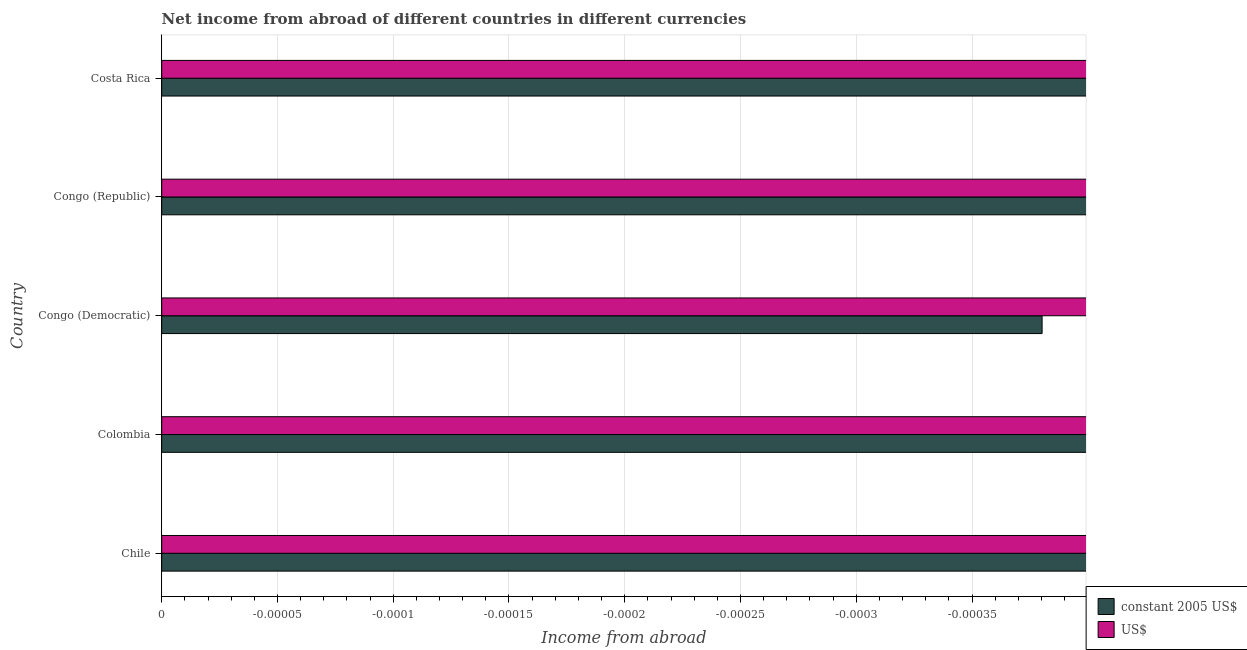How many bars are there on the 5th tick from the top?
Provide a succinct answer. 0. How many bars are there on the 5th tick from the bottom?
Provide a short and direct response. 0. What is the label of the 2nd group of bars from the top?
Ensure brevity in your answer.  Congo (Republic). What is the total income from abroad in us$ in the graph?
Offer a very short reply. 0. What is the difference between the income from abroad in constant 2005 us$ in Costa Rica and the income from abroad in us$ in Congo (Democratic)?
Give a very brief answer. 0. How many bars are there?
Your response must be concise. 0. How many countries are there in the graph?
Offer a very short reply. 5. What is the difference between two consecutive major ticks on the X-axis?
Make the answer very short. 5.000000000000002e-5. Are the values on the major ticks of X-axis written in scientific E-notation?
Keep it short and to the point. No. How many legend labels are there?
Provide a succinct answer. 2. What is the title of the graph?
Provide a short and direct response. Net income from abroad of different countries in different currencies. What is the label or title of the X-axis?
Your response must be concise. Income from abroad. What is the label or title of the Y-axis?
Ensure brevity in your answer.  Country. What is the Income from abroad of US$ in Chile?
Offer a terse response. 0. What is the Income from abroad of US$ in Congo (Democratic)?
Provide a short and direct response. 0. What is the Income from abroad in constant 2005 US$ in Congo (Republic)?
Offer a very short reply. 0. What is the Income from abroad in US$ in Congo (Republic)?
Ensure brevity in your answer.  0. What is the Income from abroad in US$ in Costa Rica?
Your answer should be very brief. 0. What is the total Income from abroad in constant 2005 US$ in the graph?
Provide a short and direct response. 0. 